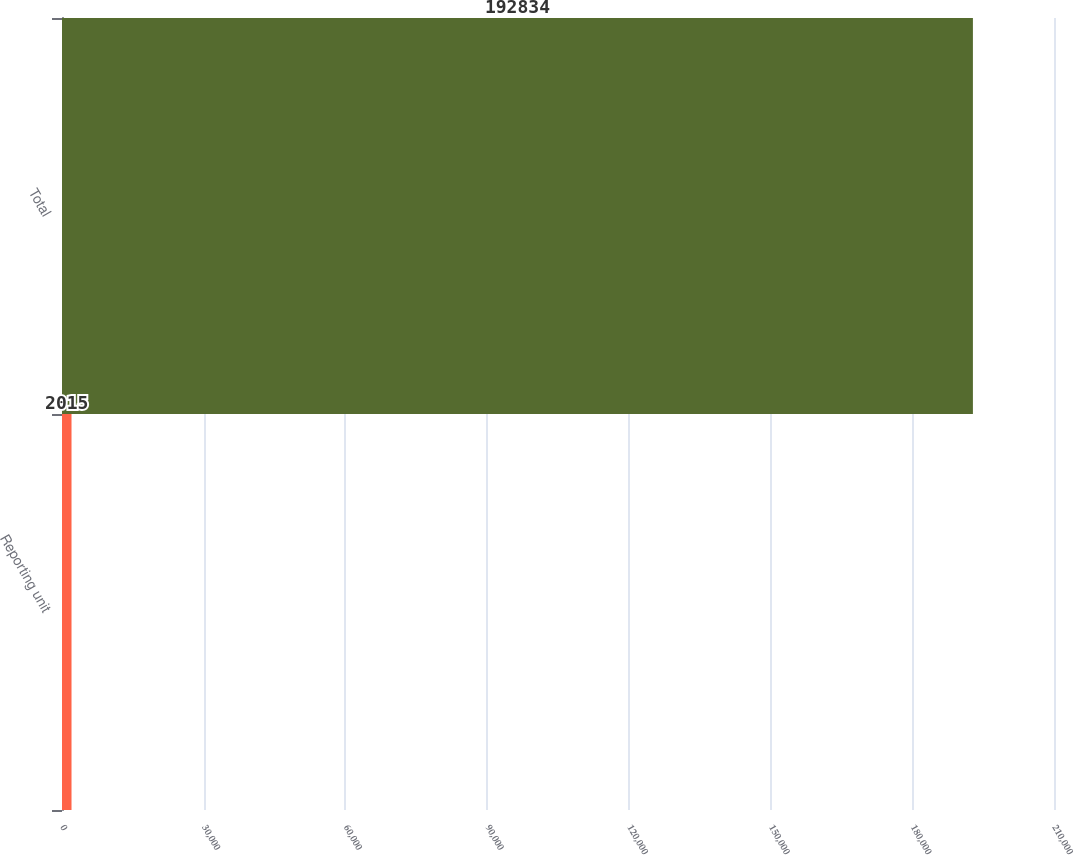<chart> <loc_0><loc_0><loc_500><loc_500><bar_chart><fcel>Reporting unit<fcel>Total<nl><fcel>2015<fcel>192834<nl></chart> 